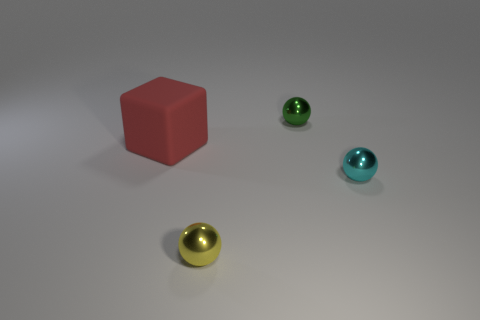The small object on the left side of the sphere behind the object that is to the left of the yellow shiny thing is made of what material?
Your response must be concise. Metal. What color is the object that is behind the large red rubber cube?
Offer a terse response. Green. Is there anything else that is the same shape as the tiny cyan shiny thing?
Your response must be concise. Yes. There is a sphere in front of the tiny metallic object to the right of the green sphere; what size is it?
Provide a succinct answer. Small. Is the number of large cubes on the right side of the tiny cyan shiny object the same as the number of small cyan shiny things behind the red block?
Offer a terse response. Yes. Is there anything else that is the same size as the yellow metal ball?
Your response must be concise. Yes. Is the large block made of the same material as the sphere that is behind the big red thing?
Keep it short and to the point. No. What color is the thing that is both on the right side of the block and behind the tiny cyan sphere?
Provide a succinct answer. Green. What number of cylinders are green objects or tiny metal objects?
Offer a terse response. 0. There is a small yellow shiny thing; does it have the same shape as the tiny shiny object behind the tiny cyan metallic sphere?
Your answer should be very brief. Yes. 